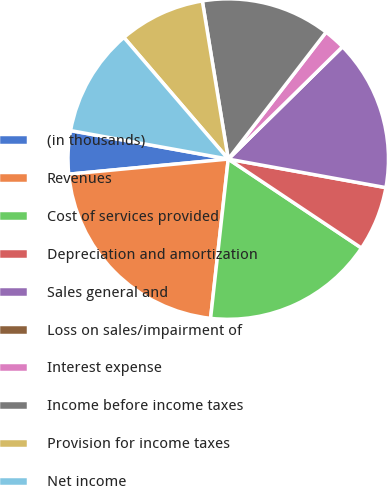<chart> <loc_0><loc_0><loc_500><loc_500><pie_chart><fcel>(in thousands)<fcel>Revenues<fcel>Cost of services provided<fcel>Depreciation and amortization<fcel>Sales general and<fcel>Loss on sales/impairment of<fcel>Interest expense<fcel>Income before income taxes<fcel>Provision for income taxes<fcel>Net income<nl><fcel>4.35%<fcel>21.74%<fcel>17.39%<fcel>6.52%<fcel>15.22%<fcel>0.0%<fcel>2.18%<fcel>13.04%<fcel>8.7%<fcel>10.87%<nl></chart> 